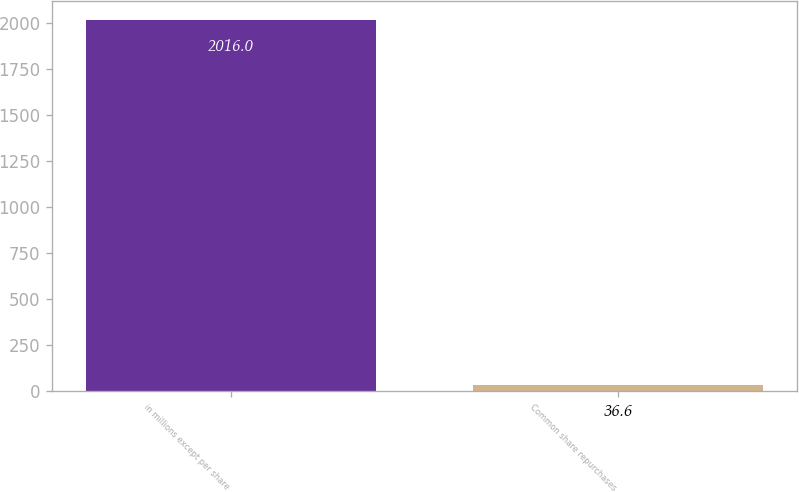Convert chart to OTSL. <chart><loc_0><loc_0><loc_500><loc_500><bar_chart><fcel>in millions except per share<fcel>Common share repurchases<nl><fcel>2016<fcel>36.6<nl></chart> 